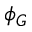Convert formula to latex. <formula><loc_0><loc_0><loc_500><loc_500>\phi _ { G }</formula> 